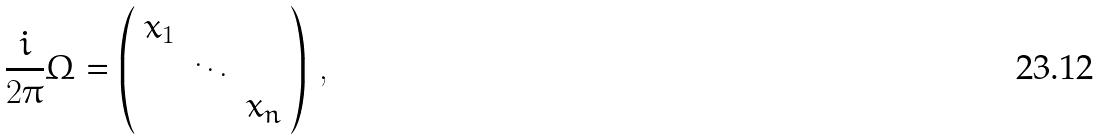Convert formula to latex. <formula><loc_0><loc_0><loc_500><loc_500>\frac { i } { 2 \pi } \Omega = \left ( \begin{array} { c c c } x _ { 1 } & & \\ & \ddots & \\ & & x _ { n } \end{array} \right ) \, ,</formula> 